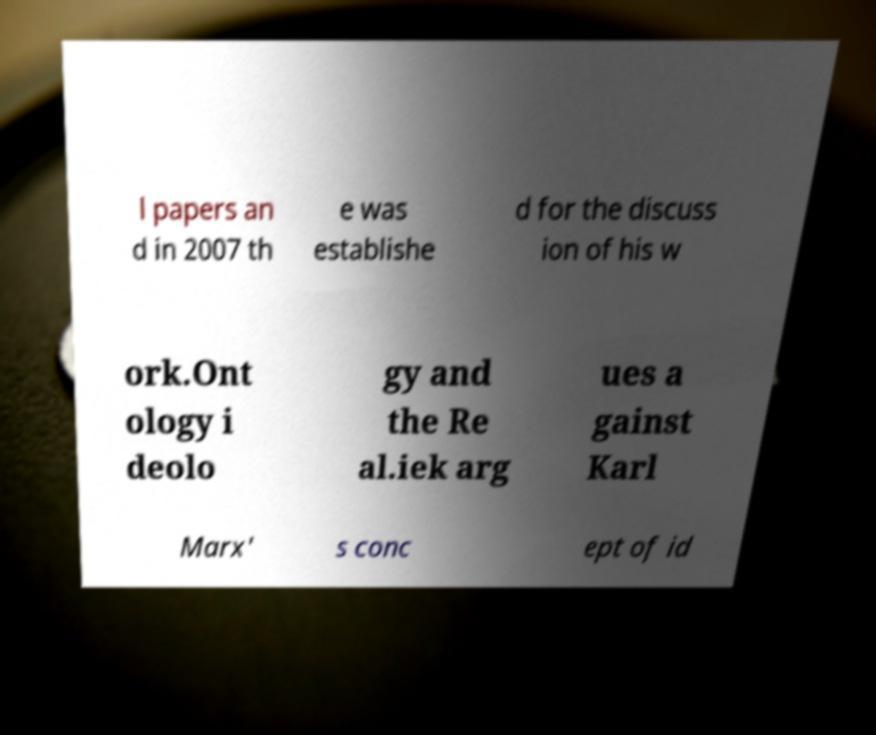Please identify and transcribe the text found in this image. l papers an d in 2007 th e was establishe d for the discuss ion of his w ork.Ont ology i deolo gy and the Re al.iek arg ues a gainst Karl Marx' s conc ept of id 